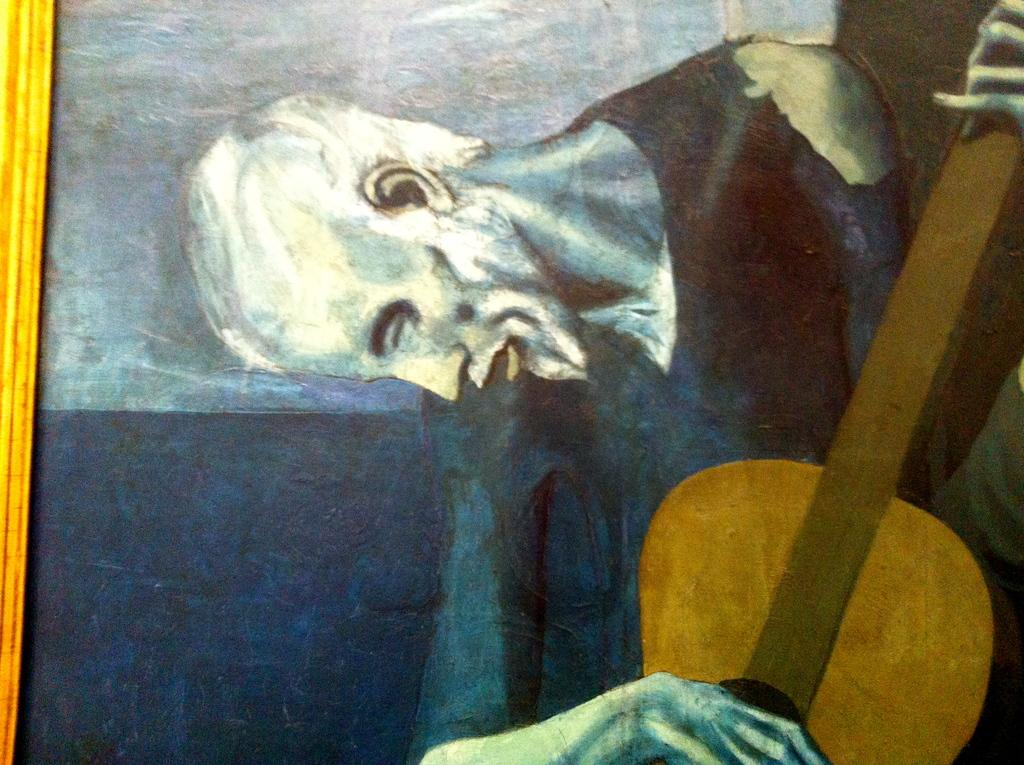What object is present in the image that typically holds a picture? There is a photo frame in the image. What can be seen inside the photo frame? The photo frame contains a picture of a man. What is the man in the picture doing? The man in the photo is holding a guitar. What type of sticks can be seen in the picture? There are no sticks present in the image; it features a photo frame with a picture of a man holding a guitar. What role does the cork play in the image? There is no cork present in the image. 